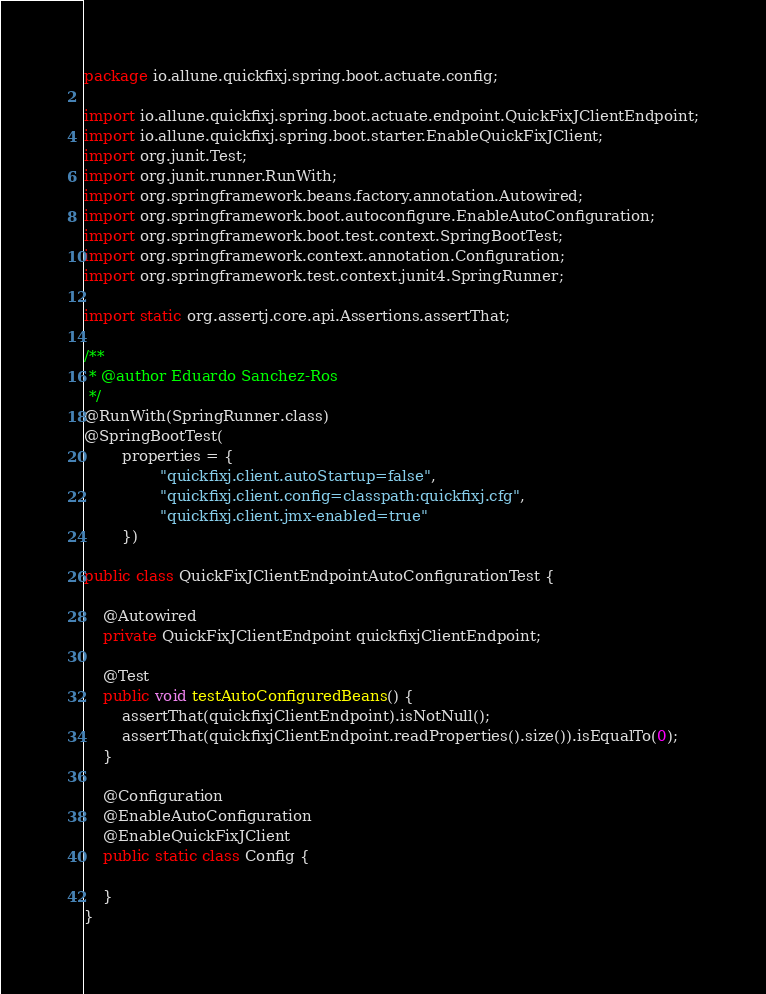<code> <loc_0><loc_0><loc_500><loc_500><_Java_>package io.allune.quickfixj.spring.boot.actuate.config;

import io.allune.quickfixj.spring.boot.actuate.endpoint.QuickFixJClientEndpoint;
import io.allune.quickfixj.spring.boot.starter.EnableQuickFixJClient;
import org.junit.Test;
import org.junit.runner.RunWith;
import org.springframework.beans.factory.annotation.Autowired;
import org.springframework.boot.autoconfigure.EnableAutoConfiguration;
import org.springframework.boot.test.context.SpringBootTest;
import org.springframework.context.annotation.Configuration;
import org.springframework.test.context.junit4.SpringRunner;

import static org.assertj.core.api.Assertions.assertThat;

/**
 * @author Eduardo Sanchez-Ros
 */
@RunWith(SpringRunner.class)
@SpringBootTest(
        properties = {
                "quickfixj.client.autoStartup=false",
                "quickfixj.client.config=classpath:quickfixj.cfg",
                "quickfixj.client.jmx-enabled=true"
        })

public class QuickFixJClientEndpointAutoConfigurationTest {

    @Autowired
    private QuickFixJClientEndpoint quickfixjClientEndpoint;

    @Test
    public void testAutoConfiguredBeans() {
        assertThat(quickfixjClientEndpoint).isNotNull();
        assertThat(quickfixjClientEndpoint.readProperties().size()).isEqualTo(0);
    }

    @Configuration
    @EnableAutoConfiguration
    @EnableQuickFixJClient
    public static class Config {

    }
}</code> 